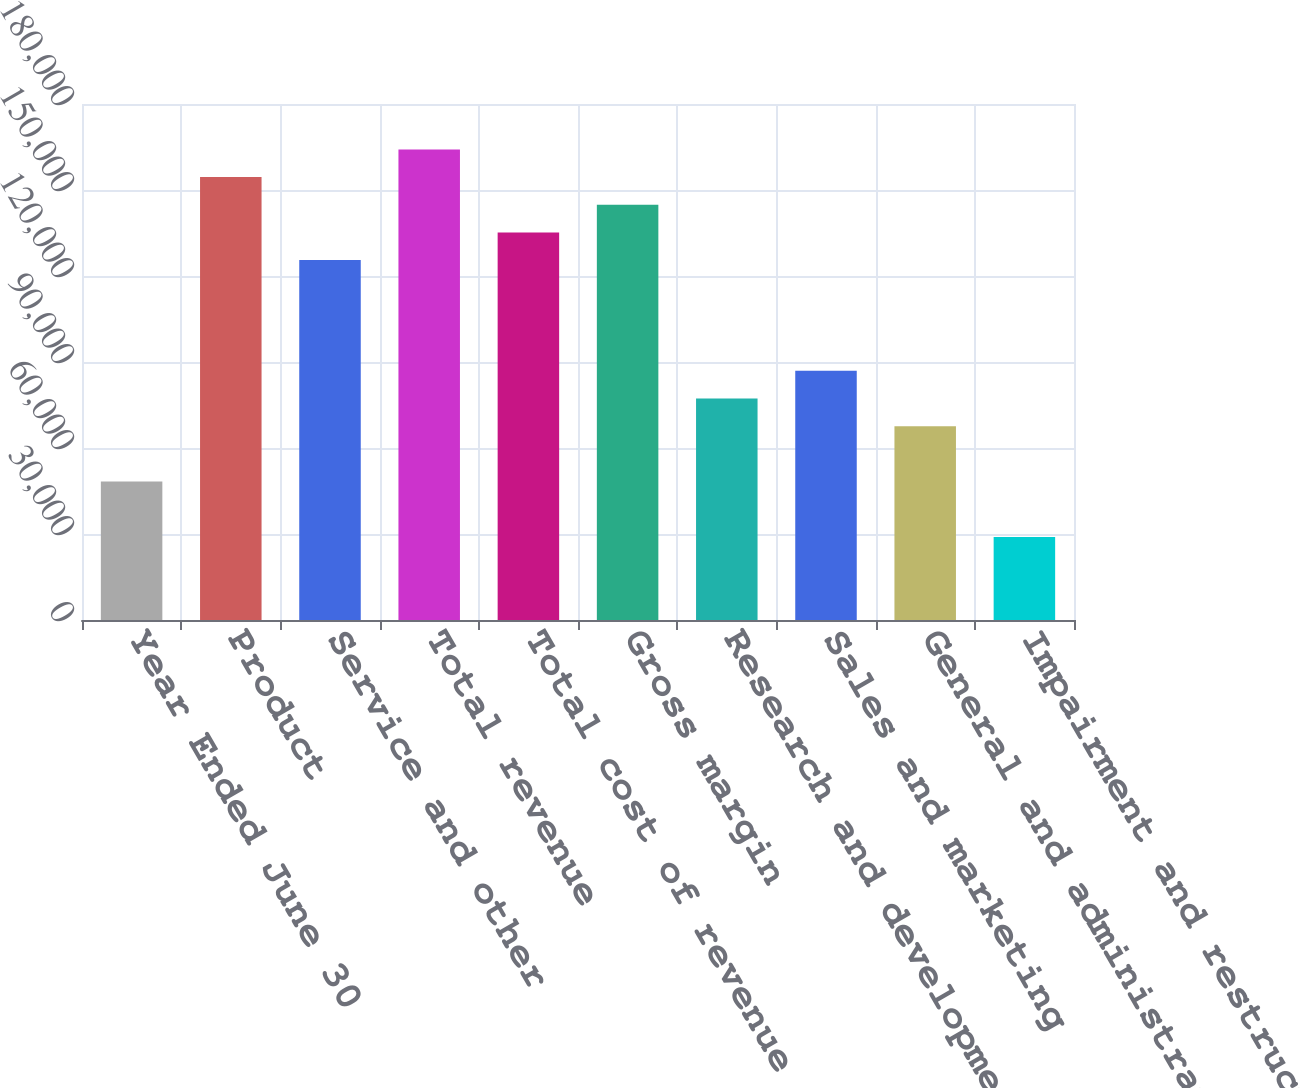Convert chart to OTSL. <chart><loc_0><loc_0><loc_500><loc_500><bar_chart><fcel>Year Ended June 30<fcel>Product<fcel>Service and other<fcel>Total revenue<fcel>Total cost of revenue<fcel>Gross margin<fcel>Research and development<fcel>Sales and marketing<fcel>General and administrative<fcel>Impairment and restructuring<nl><fcel>48286.3<fcel>154513<fcel>125542<fcel>164170<fcel>135199<fcel>144856<fcel>77257.1<fcel>86914<fcel>67600.1<fcel>28972.4<nl></chart> 